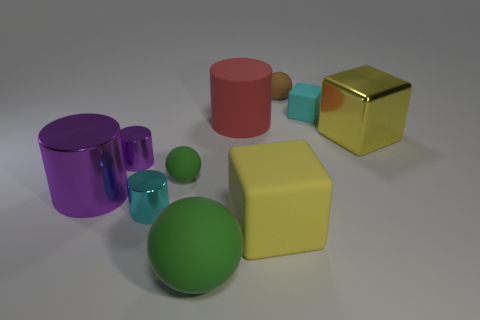Are there any patterns or themes that you can spot in the arrangement of the objects? The arrangement of objects seems to follow a theme of geometric diversity and color coding. Each shape is paired with a smaller counterpart in the same color, creating a delightful visual harmony and echoing the basic principles of shape and size categorization. 